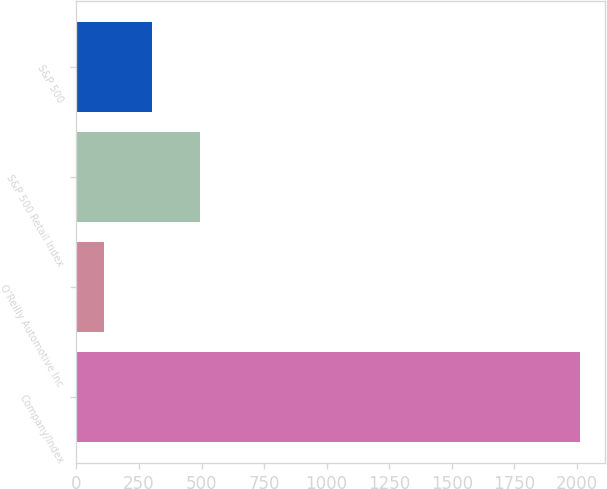Convert chart. <chart><loc_0><loc_0><loc_500><loc_500><bar_chart><fcel>Company/Index<fcel>O'Reilly Automotive Inc<fcel>S&P 500 Retail Index<fcel>S&P 500<nl><fcel>2012<fcel>112<fcel>492<fcel>302<nl></chart> 